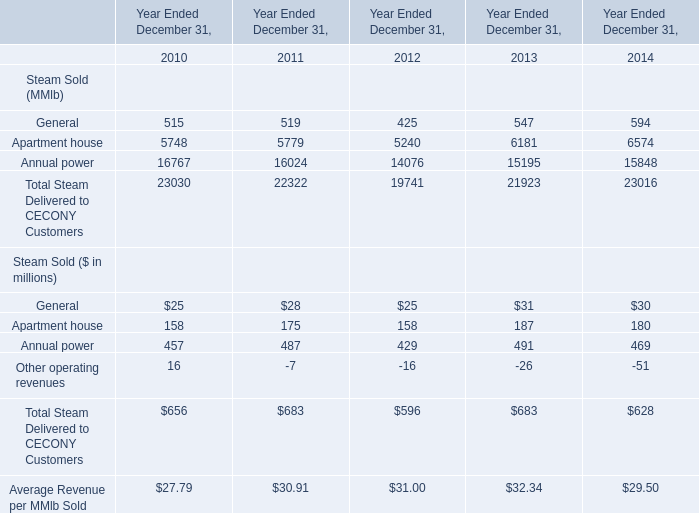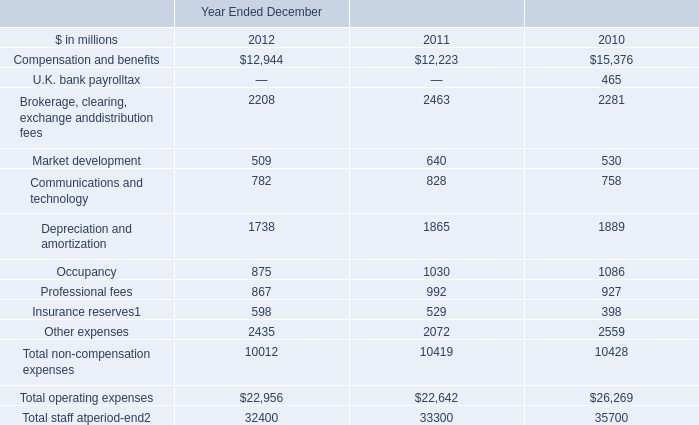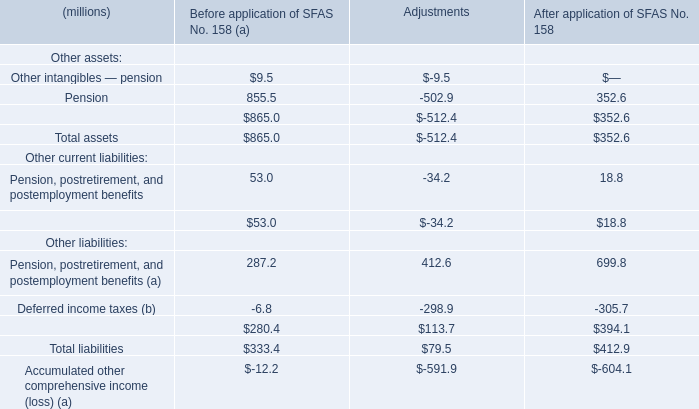what's the total amount of Depreciation and amortization of Year Ended December 2012, Annual power of Year Ended December 31, 2011, and Total operating expenses of Year Ended December 2010 ? 
Computations: ((1738.0 + 16024.0) + 26269.0)
Answer: 44031.0. What is the average amount of Brokerage, clearing, exchange anddistribution fees of Year Ended December 2010, and Apartment house of Year Ended December 31, 2014 ? 
Computations: ((2281.0 + 6574.0) / 2)
Answer: 4427.5. 